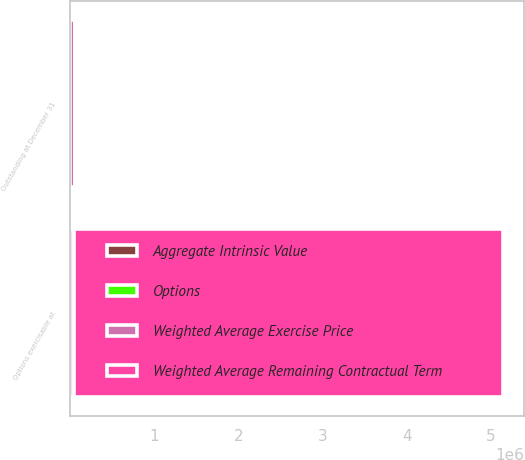Convert chart to OTSL. <chart><loc_0><loc_0><loc_500><loc_500><stacked_bar_chart><ecel><fcel>Outstanding at December 31<fcel>Options exercisable at<nl><fcel>Weighted Average Remaining Contractual Term<fcel>22.7<fcel>5.09646e+06<nl><fcel>Aggregate Intrinsic Value<fcel>22.7<fcel>17.2<nl><fcel>Options<fcel>7.3<fcel>6<nl><fcel>Weighted Average Exercise Price<fcel>50412<fcel>42674<nl></chart> 